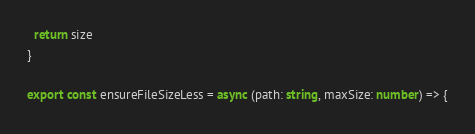<code> <loc_0><loc_0><loc_500><loc_500><_TypeScript_>  return size
}

export const ensureFileSizeLess = async (path: string, maxSize: number) => {</code> 